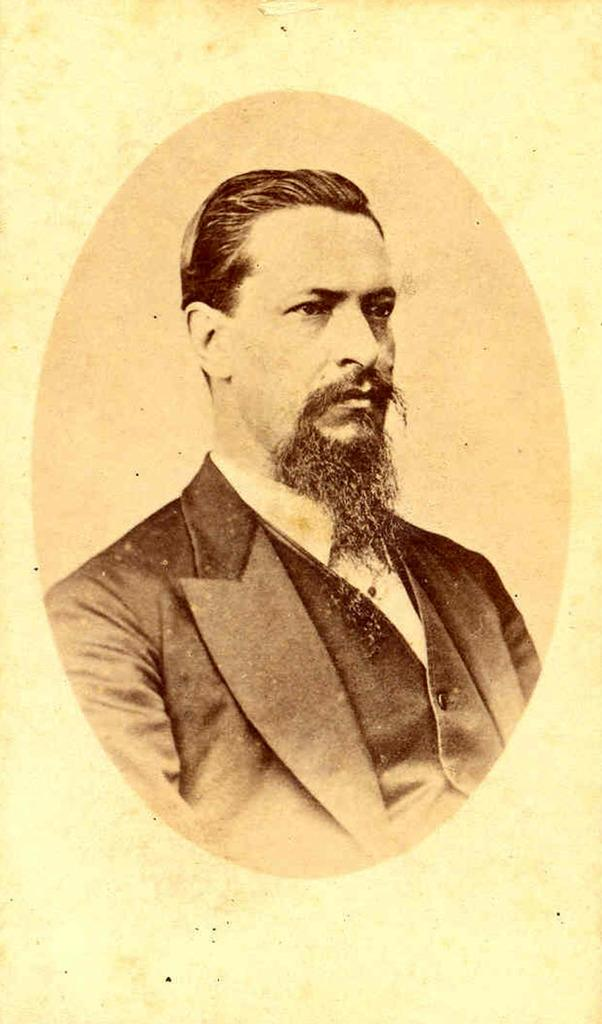Who is present in the image? There is a person in the image. What is the person wearing? The person is wearing a black dress. Can you describe any facial features of the person? The person has a beard on their face. What type of fog can be seen in the image? There is no fog present in the image. Is the person's partner visible in the image? There is no mention of a partner in the image, so it cannot be determined if they are present or not. 